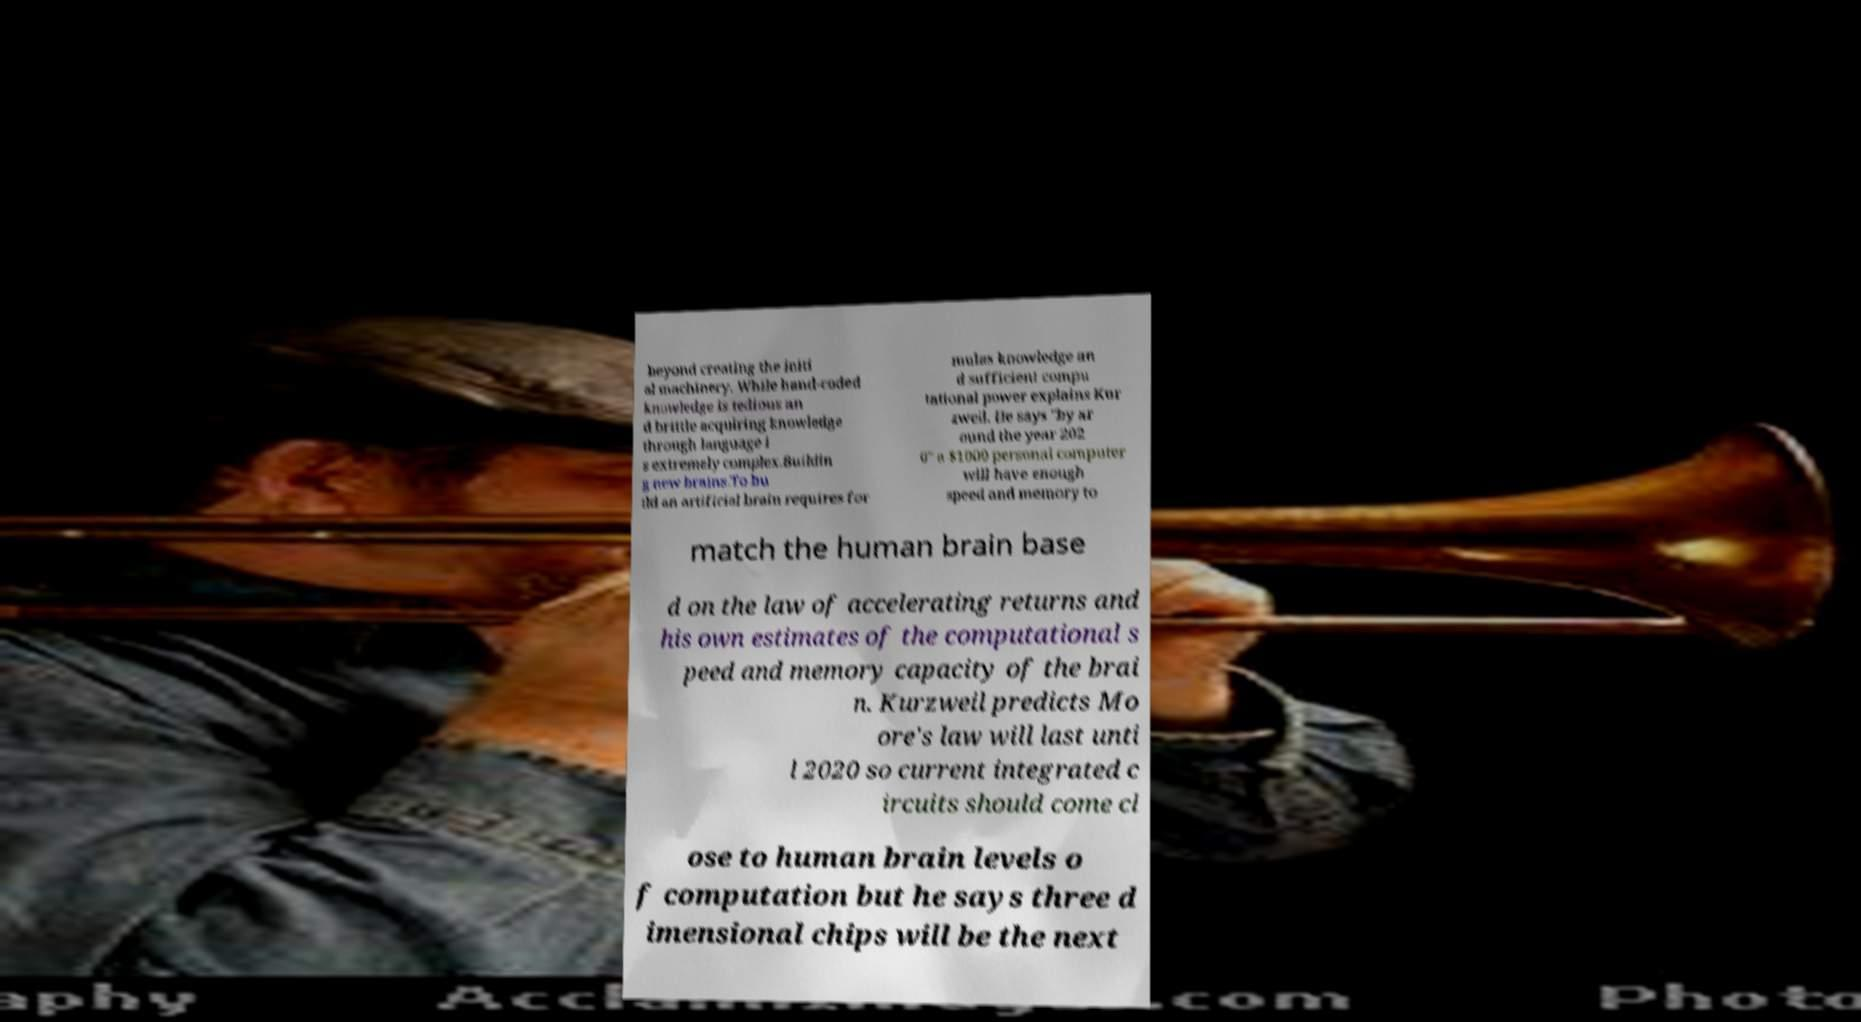I need the written content from this picture converted into text. Can you do that? beyond creating the initi al machinery. While hand-coded knowledge is tedious an d brittle acquiring knowledge through language i s extremely complex.Buildin g new brains.To bu ild an artificial brain requires for mulas knowledge an d sufficient compu tational power explains Kur zweil. He says "by ar ound the year 202 0" a $1000 personal computer will have enough speed and memory to match the human brain base d on the law of accelerating returns and his own estimates of the computational s peed and memory capacity of the brai n. Kurzweil predicts Mo ore's law will last unti l 2020 so current integrated c ircuits should come cl ose to human brain levels o f computation but he says three d imensional chips will be the next 